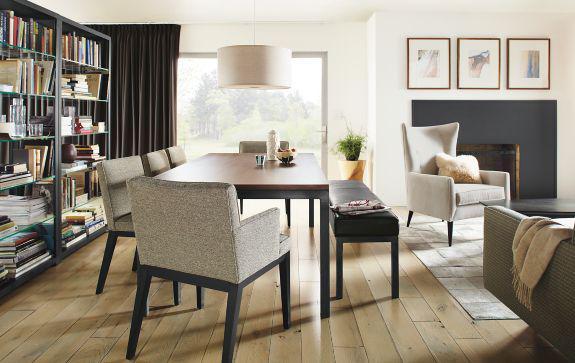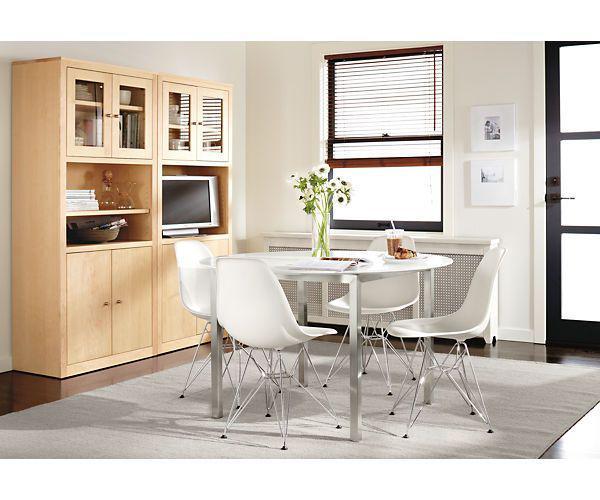The first image is the image on the left, the second image is the image on the right. Considering the images on both sides, is "Two rectangular dining tables have chairs only on both long sides." valid? Answer yes or no. No. The first image is the image on the left, the second image is the image on the right. Analyze the images presented: Is the assertion "One image includes a white table with white chairs that feature molded seats." valid? Answer yes or no. Yes. 